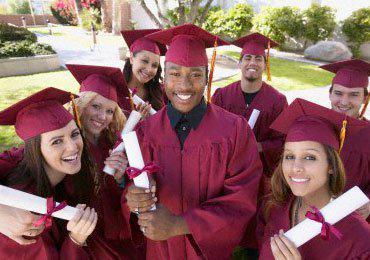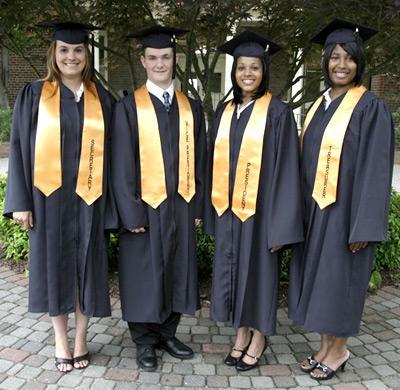The first image is the image on the left, the second image is the image on the right. Examine the images to the left and right. Is the description "At least three camera-facing graduates in burgundy robes are in one image." accurate? Answer yes or no. Yes. The first image is the image on the left, the second image is the image on the right. For the images displayed, is the sentence "In one image, at least three graduates are wearing red gowns and caps, while a second image shows at least four graduates in black gowns with gold sashes." factually correct? Answer yes or no. Yes. 